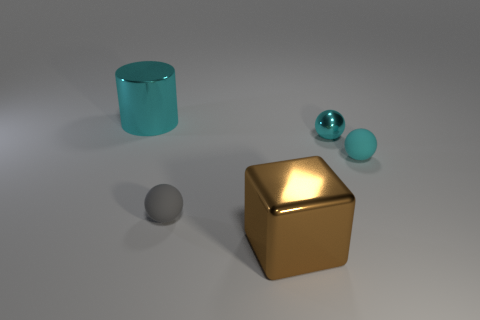Add 1 purple rubber spheres. How many objects exist? 6 Subtract all tiny matte balls. How many balls are left? 1 Subtract all cubes. How many objects are left? 4 Add 2 tiny purple balls. How many tiny purple balls exist? 2 Subtract 0 yellow blocks. How many objects are left? 5 Subtract all big cylinders. Subtract all cyan things. How many objects are left? 1 Add 5 cyan spheres. How many cyan spheres are left? 7 